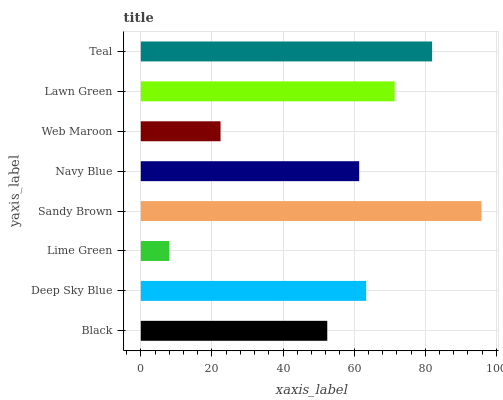Is Lime Green the minimum?
Answer yes or no. Yes. Is Sandy Brown the maximum?
Answer yes or no. Yes. Is Deep Sky Blue the minimum?
Answer yes or no. No. Is Deep Sky Blue the maximum?
Answer yes or no. No. Is Deep Sky Blue greater than Black?
Answer yes or no. Yes. Is Black less than Deep Sky Blue?
Answer yes or no. Yes. Is Black greater than Deep Sky Blue?
Answer yes or no. No. Is Deep Sky Blue less than Black?
Answer yes or no. No. Is Deep Sky Blue the high median?
Answer yes or no. Yes. Is Navy Blue the low median?
Answer yes or no. Yes. Is Teal the high median?
Answer yes or no. No. Is Lime Green the low median?
Answer yes or no. No. 